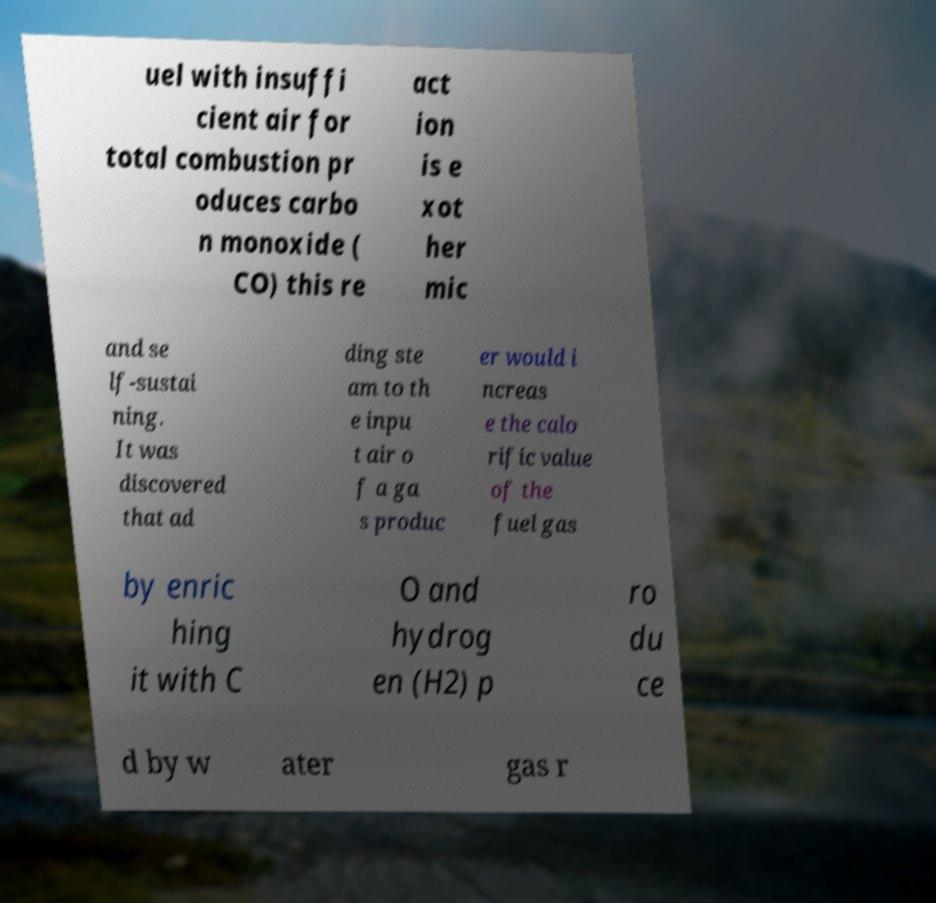Please read and relay the text visible in this image. What does it say? uel with insuffi cient air for total combustion pr oduces carbo n monoxide ( CO) this re act ion is e xot her mic and se lf-sustai ning. It was discovered that ad ding ste am to th e inpu t air o f a ga s produc er would i ncreas e the calo rific value of the fuel gas by enric hing it with C O and hydrog en (H2) p ro du ce d by w ater gas r 